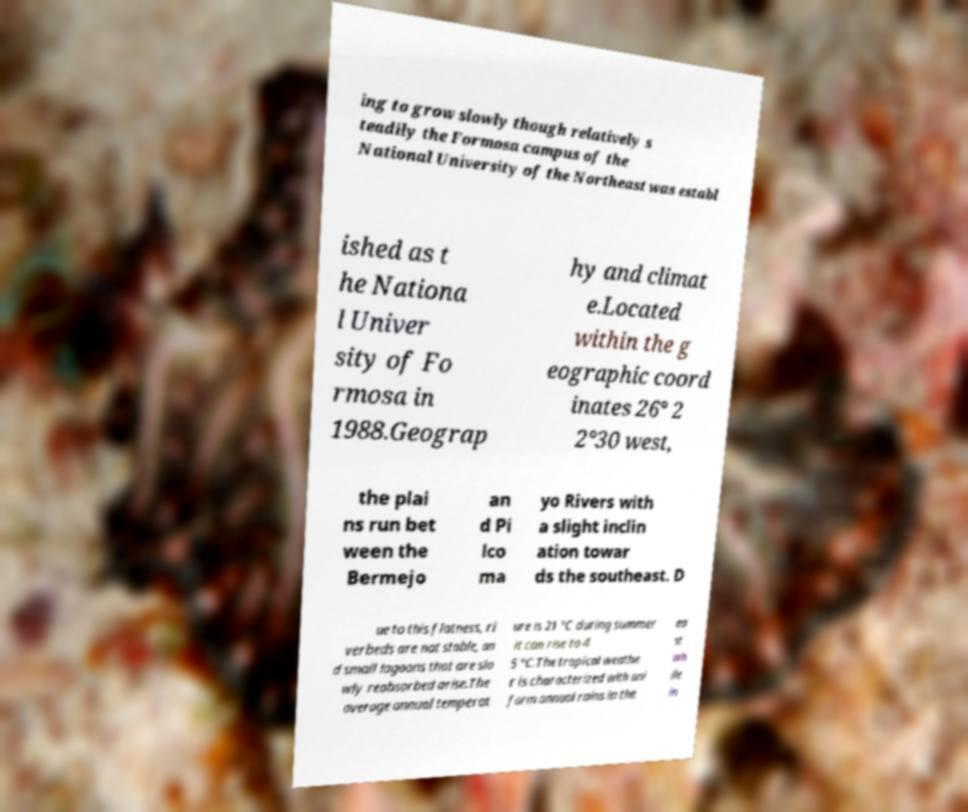I need the written content from this picture converted into text. Can you do that? ing to grow slowly though relatively s teadily the Formosa campus of the National University of the Northeast was establ ished as t he Nationa l Univer sity of Fo rmosa in 1988.Geograp hy and climat e.Located within the g eographic coord inates 26° 2 2°30 west, the plai ns run bet ween the Bermejo an d Pi lco ma yo Rivers with a slight inclin ation towar ds the southeast. D ue to this flatness, ri verbeds are not stable, an d small lagoons that are slo wly reabsorbed arise.The average annual temperat ure is 21 °C during summer it can rise to 4 5 °C.The tropical weathe r is characterized with uni form annual rains in the ea st wh ile in 